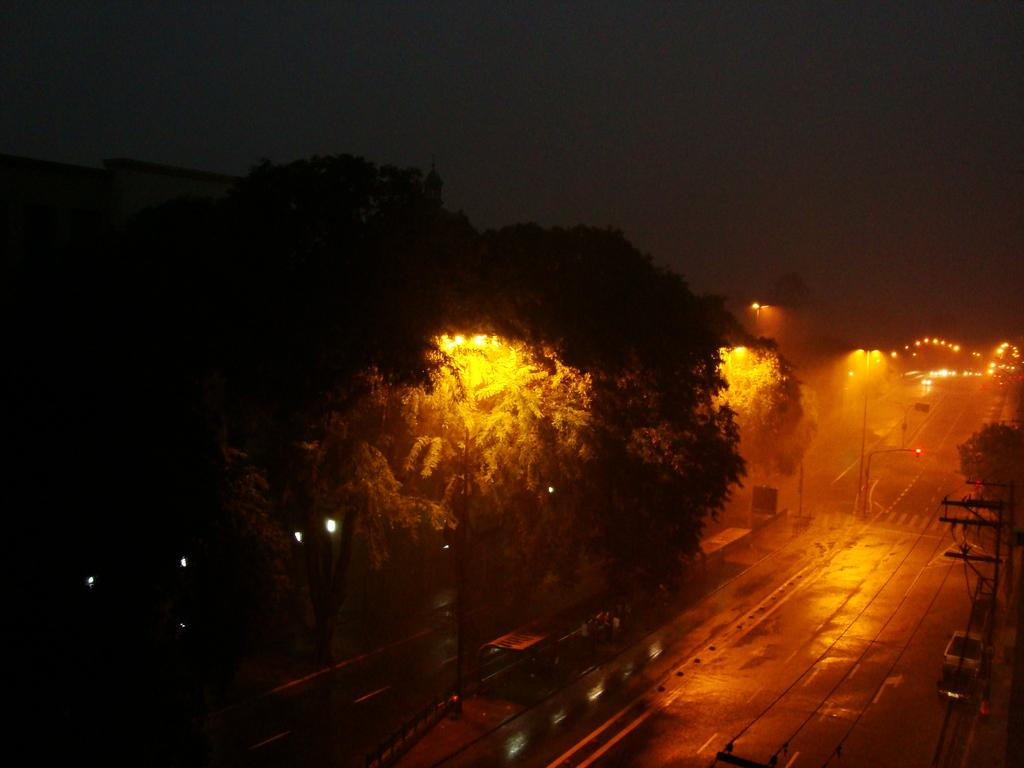What type of infrastructure is visible in the image? There are roads and street light poles in the image. Where is the electric pole located in the image? The electric pole is on the right side of the image. What type of vegetation is on the left side of the image? There are trees on the left side of the image. Can you tell me how many caves are visible in the image? There are no caves present in the image. What type of war is being depicted in the image? There is no depiction of war in the image; it features roads, street light poles, an electric pole, and trees. 